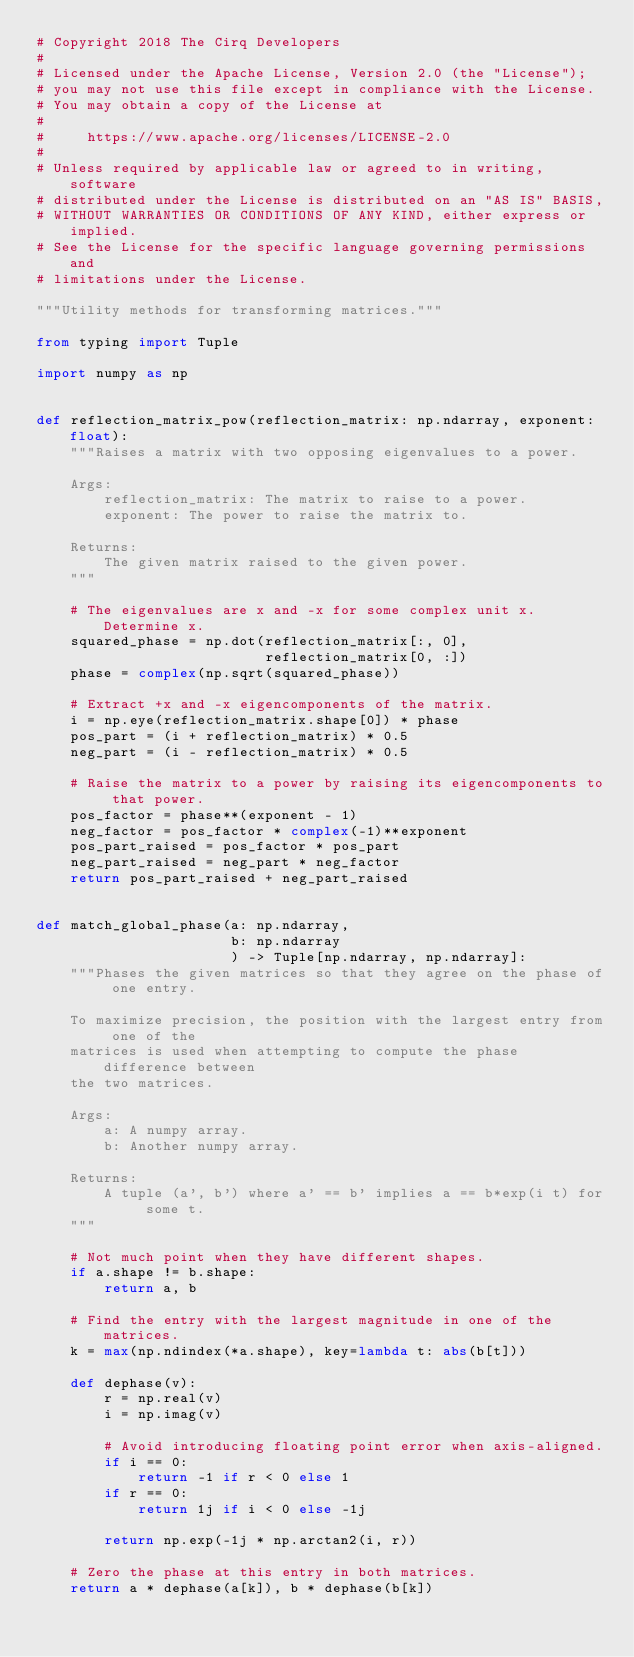<code> <loc_0><loc_0><loc_500><loc_500><_Python_># Copyright 2018 The Cirq Developers
#
# Licensed under the Apache License, Version 2.0 (the "License");
# you may not use this file except in compliance with the License.
# You may obtain a copy of the License at
#
#     https://www.apache.org/licenses/LICENSE-2.0
#
# Unless required by applicable law or agreed to in writing, software
# distributed under the License is distributed on an "AS IS" BASIS,
# WITHOUT WARRANTIES OR CONDITIONS OF ANY KIND, either express or implied.
# See the License for the specific language governing permissions and
# limitations under the License.

"""Utility methods for transforming matrices."""

from typing import Tuple

import numpy as np


def reflection_matrix_pow(reflection_matrix: np.ndarray, exponent: float):
    """Raises a matrix with two opposing eigenvalues to a power.

    Args:
        reflection_matrix: The matrix to raise to a power.
        exponent: The power to raise the matrix to.

    Returns:
        The given matrix raised to the given power.
    """

    # The eigenvalues are x and -x for some complex unit x. Determine x.
    squared_phase = np.dot(reflection_matrix[:, 0],
                           reflection_matrix[0, :])
    phase = complex(np.sqrt(squared_phase))

    # Extract +x and -x eigencomponents of the matrix.
    i = np.eye(reflection_matrix.shape[0]) * phase
    pos_part = (i + reflection_matrix) * 0.5
    neg_part = (i - reflection_matrix) * 0.5

    # Raise the matrix to a power by raising its eigencomponents to that power.
    pos_factor = phase**(exponent - 1)
    neg_factor = pos_factor * complex(-1)**exponent
    pos_part_raised = pos_factor * pos_part
    neg_part_raised = neg_part * neg_factor
    return pos_part_raised + neg_part_raised


def match_global_phase(a: np.ndarray,
                       b: np.ndarray
                       ) -> Tuple[np.ndarray, np.ndarray]:
    """Phases the given matrices so that they agree on the phase of one entry.

    To maximize precision, the position with the largest entry from one of the
    matrices is used when attempting to compute the phase difference between
    the two matrices.

    Args:
        a: A numpy array.
        b: Another numpy array.

    Returns:
        A tuple (a', b') where a' == b' implies a == b*exp(i t) for some t.
    """

    # Not much point when they have different shapes.
    if a.shape != b.shape:
        return a, b

    # Find the entry with the largest magnitude in one of the matrices.
    k = max(np.ndindex(*a.shape), key=lambda t: abs(b[t]))

    def dephase(v):
        r = np.real(v)
        i = np.imag(v)

        # Avoid introducing floating point error when axis-aligned.
        if i == 0:
            return -1 if r < 0 else 1
        if r == 0:
            return 1j if i < 0 else -1j

        return np.exp(-1j * np.arctan2(i, r))

    # Zero the phase at this entry in both matrices.
    return a * dephase(a[k]), b * dephase(b[k])
</code> 